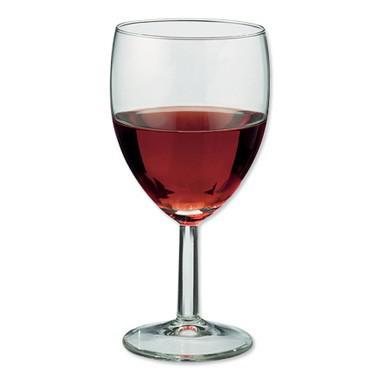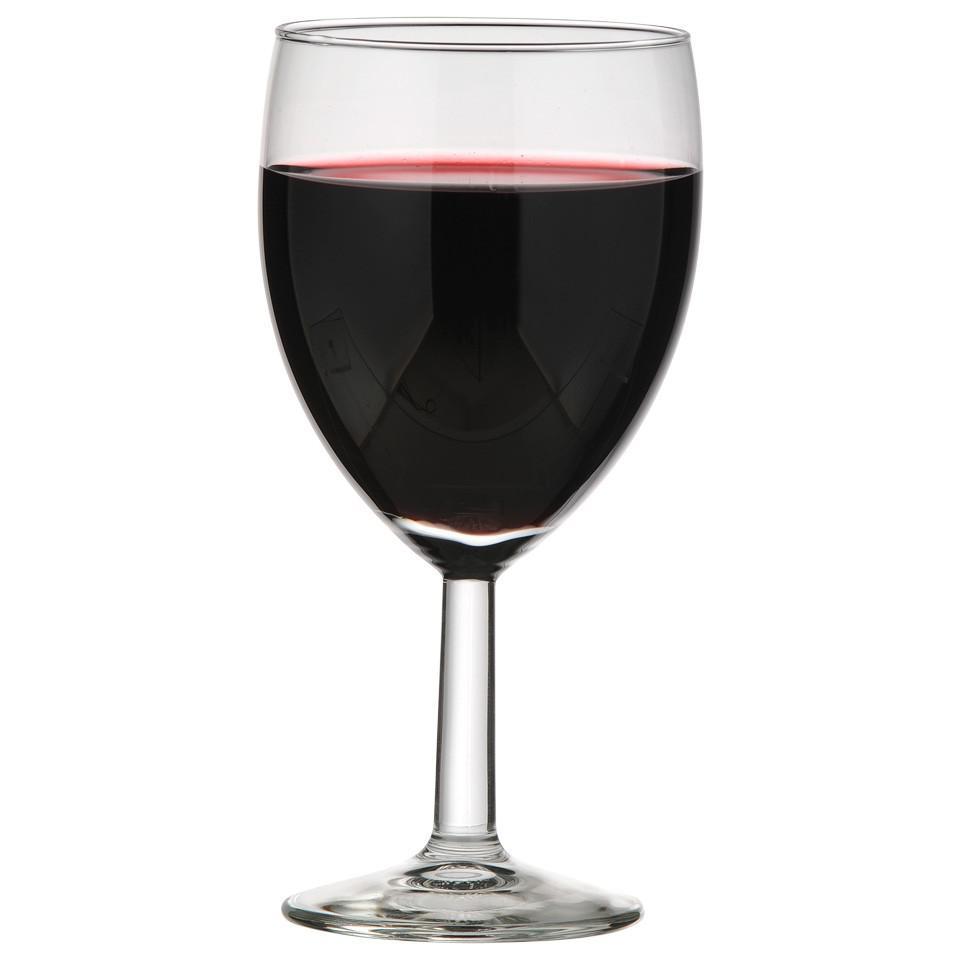The first image is the image on the left, the second image is the image on the right. For the images shown, is this caption "There is at least two wine glasses in the right image." true? Answer yes or no. No. 